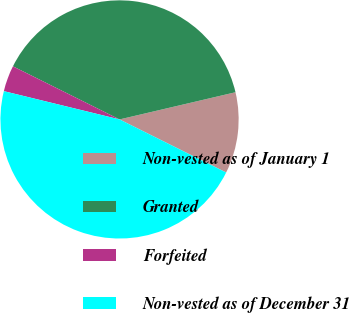Convert chart to OTSL. <chart><loc_0><loc_0><loc_500><loc_500><pie_chart><fcel>Non-vested as of January 1<fcel>Granted<fcel>Forfeited<fcel>Non-vested as of December 31<nl><fcel>11.02%<fcel>38.98%<fcel>3.54%<fcel>46.46%<nl></chart> 